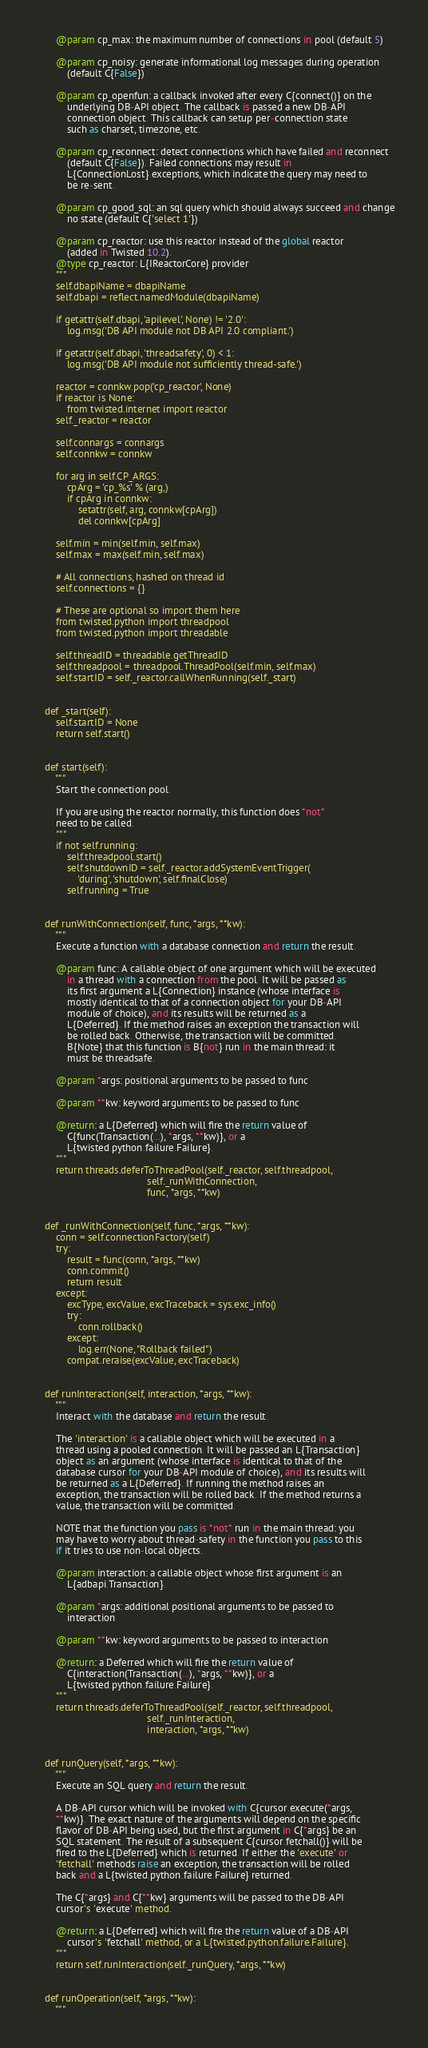Convert code to text. <code><loc_0><loc_0><loc_500><loc_500><_Python_>        @param cp_max: the maximum number of connections in pool (default 5)

        @param cp_noisy: generate informational log messages during operation
            (default C{False})

        @param cp_openfun: a callback invoked after every C{connect()} on the
            underlying DB-API object. The callback is passed a new DB-API
            connection object. This callback can setup per-connection state
            such as charset, timezone, etc.

        @param cp_reconnect: detect connections which have failed and reconnect
            (default C{False}). Failed connections may result in
            L{ConnectionLost} exceptions, which indicate the query may need to
            be re-sent.

        @param cp_good_sql: an sql query which should always succeed and change
            no state (default C{'select 1'})

        @param cp_reactor: use this reactor instead of the global reactor
            (added in Twisted 10.2).
        @type cp_reactor: L{IReactorCore} provider
        """
        self.dbapiName = dbapiName
        self.dbapi = reflect.namedModule(dbapiName)

        if getattr(self.dbapi, 'apilevel', None) != '2.0':
            log.msg('DB API module not DB API 2.0 compliant.')

        if getattr(self.dbapi, 'threadsafety', 0) < 1:
            log.msg('DB API module not sufficiently thread-safe.')

        reactor = connkw.pop('cp_reactor', None)
        if reactor is None:
            from twisted.internet import reactor
        self._reactor = reactor

        self.connargs = connargs
        self.connkw = connkw

        for arg in self.CP_ARGS:
            cpArg = 'cp_%s' % (arg,)
            if cpArg in connkw:
                setattr(self, arg, connkw[cpArg])
                del connkw[cpArg]

        self.min = min(self.min, self.max)
        self.max = max(self.min, self.max)

        # All connections, hashed on thread id
        self.connections = {}

        # These are optional so import them here
        from twisted.python import threadpool
        from twisted.python import threadable

        self.threadID = threadable.getThreadID
        self.threadpool = threadpool.ThreadPool(self.min, self.max)
        self.startID = self._reactor.callWhenRunning(self._start)


    def _start(self):
        self.startID = None
        return self.start()


    def start(self):
        """
        Start the connection pool.

        If you are using the reactor normally, this function does *not*
        need to be called.
        """
        if not self.running:
            self.threadpool.start()
            self.shutdownID = self._reactor.addSystemEventTrigger(
                'during', 'shutdown', self.finalClose)
            self.running = True


    def runWithConnection(self, func, *args, **kw):
        """
        Execute a function with a database connection and return the result.

        @param func: A callable object of one argument which will be executed
            in a thread with a connection from the pool. It will be passed as
            its first argument a L{Connection} instance (whose interface is
            mostly identical to that of a connection object for your DB-API
            module of choice), and its results will be returned as a
            L{Deferred}. If the method raises an exception the transaction will
            be rolled back. Otherwise, the transaction will be committed.
            B{Note} that this function is B{not} run in the main thread: it
            must be threadsafe.

        @param *args: positional arguments to be passed to func

        @param **kw: keyword arguments to be passed to func

        @return: a L{Deferred} which will fire the return value of
            C{func(Transaction(...), *args, **kw)}, or a
            L{twisted.python.failure.Failure}.
        """
        return threads.deferToThreadPool(self._reactor, self.threadpool,
                                         self._runWithConnection,
                                         func, *args, **kw)


    def _runWithConnection(self, func, *args, **kw):
        conn = self.connectionFactory(self)
        try:
            result = func(conn, *args, **kw)
            conn.commit()
            return result
        except:
            excType, excValue, excTraceback = sys.exc_info()
            try:
                conn.rollback()
            except:
                log.err(None, "Rollback failed")
            compat.reraise(excValue, excTraceback)


    def runInteraction(self, interaction, *args, **kw):
        """
        Interact with the database and return the result.

        The 'interaction' is a callable object which will be executed in a
        thread using a pooled connection. It will be passed an L{Transaction}
        object as an argument (whose interface is identical to that of the
        database cursor for your DB-API module of choice), and its results will
        be returned as a L{Deferred}. If running the method raises an
        exception, the transaction will be rolled back. If the method returns a
        value, the transaction will be committed.

        NOTE that the function you pass is *not* run in the main thread: you
        may have to worry about thread-safety in the function you pass to this
        if it tries to use non-local objects.

        @param interaction: a callable object whose first argument is an
            L{adbapi.Transaction}.

        @param *args: additional positional arguments to be passed to
            interaction

        @param **kw: keyword arguments to be passed to interaction

        @return: a Deferred which will fire the return value of
            C{interaction(Transaction(...), *args, **kw)}, or a
            L{twisted.python.failure.Failure}.
        """
        return threads.deferToThreadPool(self._reactor, self.threadpool,
                                         self._runInteraction,
                                         interaction, *args, **kw)


    def runQuery(self, *args, **kw):
        """
        Execute an SQL query and return the result.

        A DB-API cursor which will be invoked with C{cursor.execute(*args,
        **kw)}. The exact nature of the arguments will depend on the specific
        flavor of DB-API being used, but the first argument in C{*args} be an
        SQL statement. The result of a subsequent C{cursor.fetchall()} will be
        fired to the L{Deferred} which is returned. If either the 'execute' or
        'fetchall' methods raise an exception, the transaction will be rolled
        back and a L{twisted.python.failure.Failure} returned.

        The C{*args} and C{**kw} arguments will be passed to the DB-API
        cursor's 'execute' method.

        @return: a L{Deferred} which will fire the return value of a DB-API
            cursor's 'fetchall' method, or a L{twisted.python.failure.Failure}.
        """
        return self.runInteraction(self._runQuery, *args, **kw)


    def runOperation(self, *args, **kw):
        """</code> 